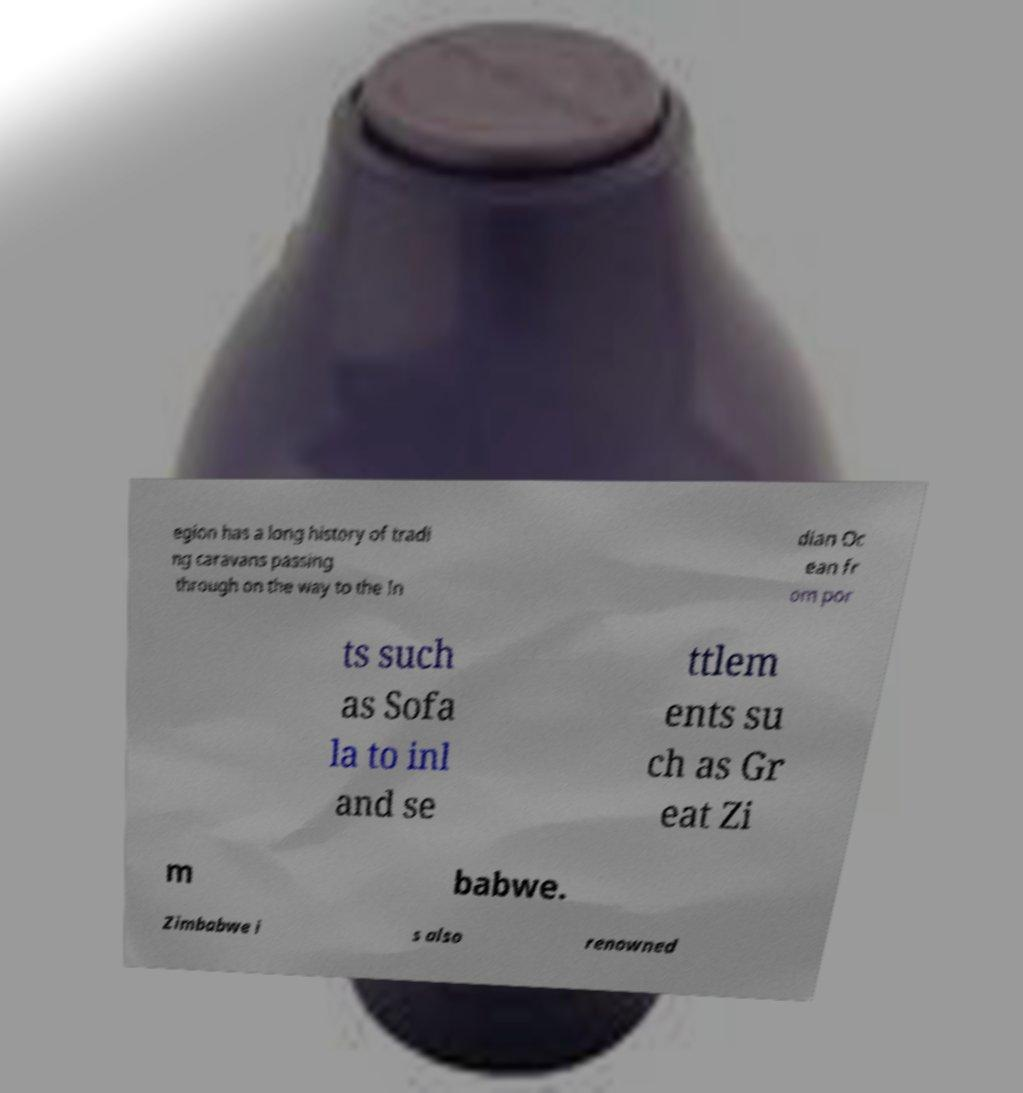Could you extract and type out the text from this image? egion has a long history of tradi ng caravans passing through on the way to the In dian Oc ean fr om por ts such as Sofa la to inl and se ttlem ents su ch as Gr eat Zi m babwe. Zimbabwe i s also renowned 